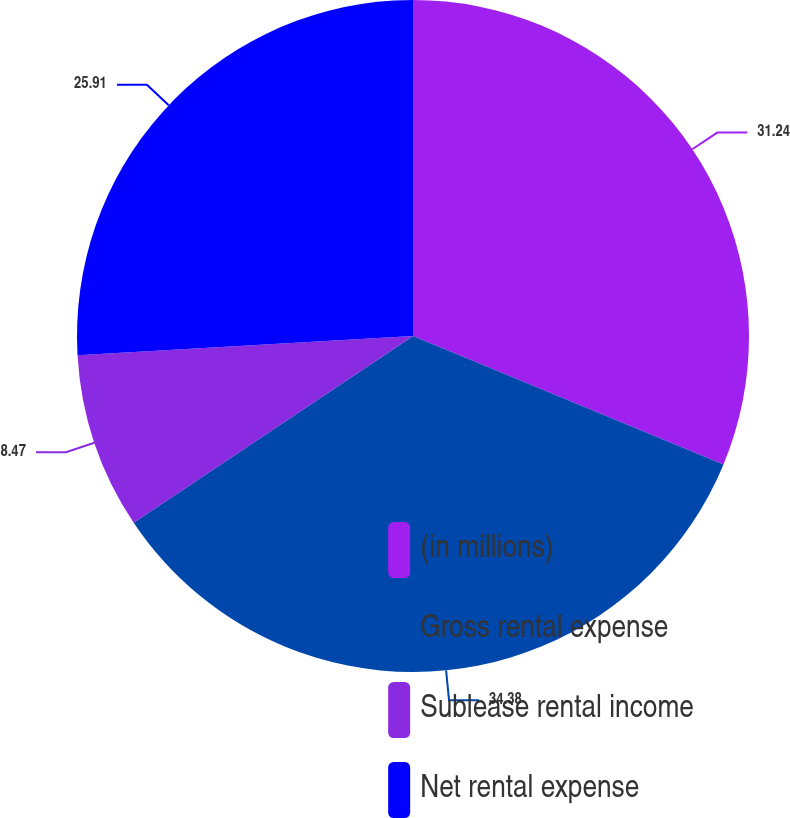Convert chart. <chart><loc_0><loc_0><loc_500><loc_500><pie_chart><fcel>(in millions)<fcel>Gross rental expense<fcel>Sublease rental income<fcel>Net rental expense<nl><fcel>31.24%<fcel>34.38%<fcel>8.47%<fcel>25.91%<nl></chart> 